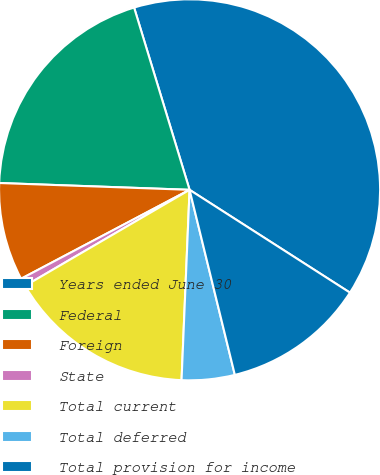<chart> <loc_0><loc_0><loc_500><loc_500><pie_chart><fcel>Years ended June 30<fcel>Federal<fcel>Foreign<fcel>State<fcel>Total current<fcel>Total deferred<fcel>Total provision for income<nl><fcel>38.78%<fcel>19.73%<fcel>8.3%<fcel>0.68%<fcel>15.92%<fcel>4.49%<fcel>12.11%<nl></chart> 